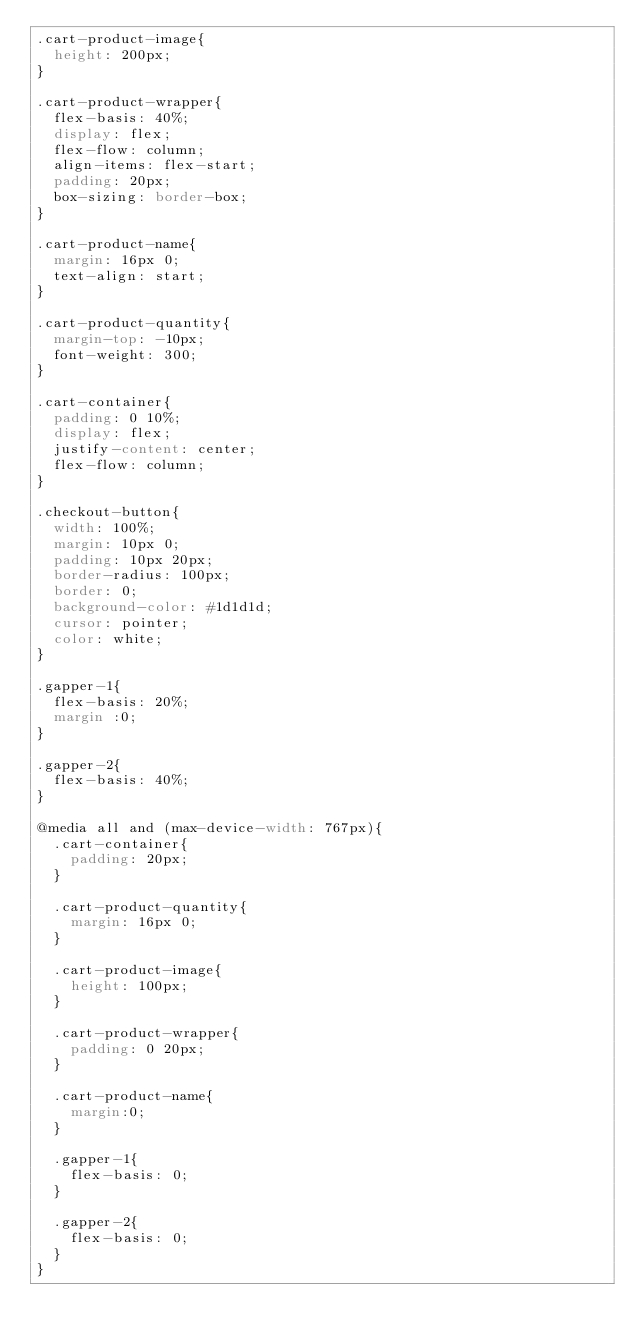Convert code to text. <code><loc_0><loc_0><loc_500><loc_500><_CSS_>.cart-product-image{
  height: 200px;
}

.cart-product-wrapper{
  flex-basis: 40%;
  display: flex;
  flex-flow: column;
  align-items: flex-start;
  padding: 20px;
  box-sizing: border-box;
}

.cart-product-name{
  margin: 16px 0;
  text-align: start;
}

.cart-product-quantity{
  margin-top: -10px;
  font-weight: 300;
}

.cart-container{
  padding: 0 10%;
  display: flex;
  justify-content: center;
  flex-flow: column;
}

.checkout-button{
  width: 100%;
  margin: 10px 0;
  padding: 10px 20px;
  border-radius: 100px;
  border: 0;
  background-color: #1d1d1d;
  cursor: pointer;
  color: white;
}

.gapper-1{
  flex-basis: 20%;
  margin :0;
}

.gapper-2{
  flex-basis: 40%;
}

@media all and (max-device-width: 767px){
  .cart-container{
    padding: 20px;
  }

  .cart-product-quantity{
    margin: 16px 0;
  }

  .cart-product-image{
    height: 100px;
  }

  .cart-product-wrapper{
    padding: 0 20px;
  }
  
  .cart-product-name{
    margin:0;
  }

  .gapper-1{
    flex-basis: 0;
  }

  .gapper-2{
    flex-basis: 0;
  }
}</code> 